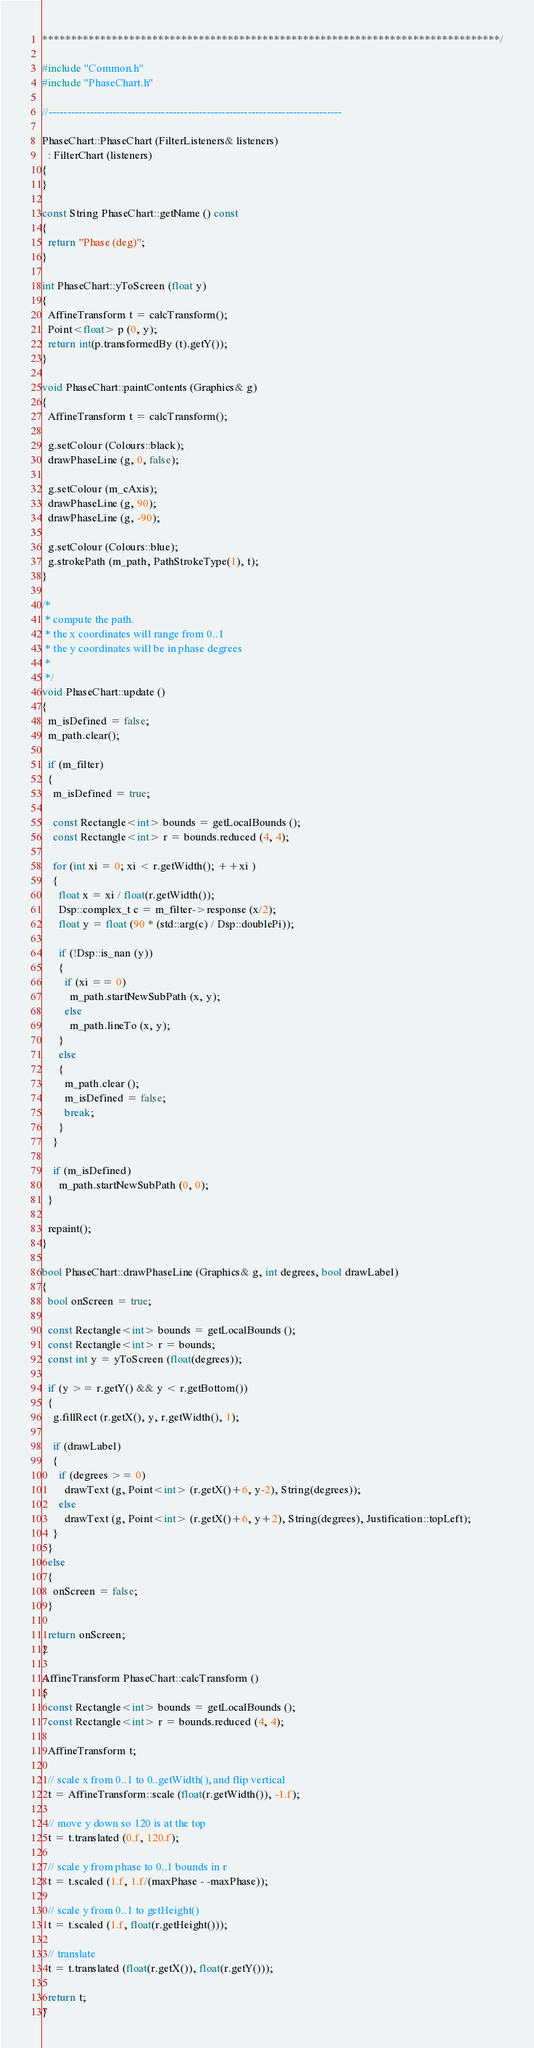<code> <loc_0><loc_0><loc_500><loc_500><_C++_>*******************************************************************************/

#include "Common.h"
#include "PhaseChart.h"

//------------------------------------------------------------------------------

PhaseChart::PhaseChart (FilterListeners& listeners)
  : FilterChart (listeners)
{
}

const String PhaseChart::getName () const
{
  return "Phase (deg)";
}

int PhaseChart::yToScreen (float y)
{
  AffineTransform t = calcTransform();
  Point<float> p (0, y);
  return int(p.transformedBy (t).getY());
}

void PhaseChart::paintContents (Graphics& g)
{
  AffineTransform t = calcTransform();

  g.setColour (Colours::black);
  drawPhaseLine (g, 0, false);

  g.setColour (m_cAxis);
  drawPhaseLine (g, 90);
  drawPhaseLine (g, -90);

  g.setColour (Colours::blue);
  g.strokePath (m_path, PathStrokeType(1), t);
}

/*
 * compute the path.
 * the x coordinates will range from 0..1
 * the y coordinates will be in phase degrees
 *
 */
void PhaseChart::update ()
{
  m_isDefined = false;
  m_path.clear();

  if (m_filter)
  {
    m_isDefined = true;

    const Rectangle<int> bounds = getLocalBounds ();
    const Rectangle<int> r = bounds.reduced (4, 4);

    for (int xi = 0; xi < r.getWidth(); ++xi )
    {
      float x = xi / float(r.getWidth());
      Dsp::complex_t c = m_filter->response (x/2);
      float y = float (90 * (std::arg(c) / Dsp::doublePi));

      if (!Dsp::is_nan (y))
      {
        if (xi == 0)
          m_path.startNewSubPath (x, y);
        else
          m_path.lineTo (x, y);
      }
      else
      {
        m_path.clear ();
        m_isDefined = false;
        break;
      }
    }

    if (m_isDefined)
      m_path.startNewSubPath (0, 0);
  }

  repaint();
}

bool PhaseChart::drawPhaseLine (Graphics& g, int degrees, bool drawLabel)
{
  bool onScreen = true;

  const Rectangle<int> bounds = getLocalBounds ();
  const Rectangle<int> r = bounds;
  const int y = yToScreen (float(degrees));

  if (y >= r.getY() && y < r.getBottom())
  {
    g.fillRect (r.getX(), y, r.getWidth(), 1);

    if (drawLabel)
    {
      if (degrees >= 0)
        drawText (g, Point<int> (r.getX()+6, y-2), String(degrees));
      else
        drawText (g, Point<int> (r.getX()+6, y+2), String(degrees), Justification::topLeft);
    }
  }
  else
  {
    onScreen = false;
  }

  return onScreen;
}

AffineTransform PhaseChart::calcTransform ()
{
  const Rectangle<int> bounds = getLocalBounds ();
  const Rectangle<int> r = bounds.reduced (4, 4);

  AffineTransform t;

  // scale x from 0..1 to 0..getWidth(), and flip vertical
  t = AffineTransform::scale (float(r.getWidth()), -1.f);

  // move y down so 120 is at the top
  t = t.translated (0.f, 120.f);

  // scale y from phase to 0..1 bounds in r
  t = t.scaled (1.f, 1.f/(maxPhase - -maxPhase));

  // scale y from 0..1 to getHeight()
  t = t.scaled (1.f, float(r.getHeight()));

  // translate
  t = t.translated (float(r.getX()), float(r.getY()));

  return t;
}
</code> 